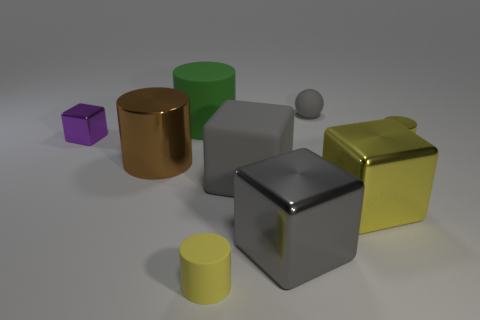How many yellow cylinders must be subtracted to get 1 yellow cylinders? 1 Subtract 1 cylinders. How many cylinders are left? 3 Subtract all purple balls. Subtract all red blocks. How many balls are left? 1 Add 1 large green cylinders. How many objects exist? 10 Subtract all blocks. How many objects are left? 5 Subtract 0 blue cylinders. How many objects are left? 9 Subtract all small yellow shiny cylinders. Subtract all big rubber cylinders. How many objects are left? 7 Add 1 purple metallic objects. How many purple metallic objects are left? 2 Add 1 tiny objects. How many tiny objects exist? 5 